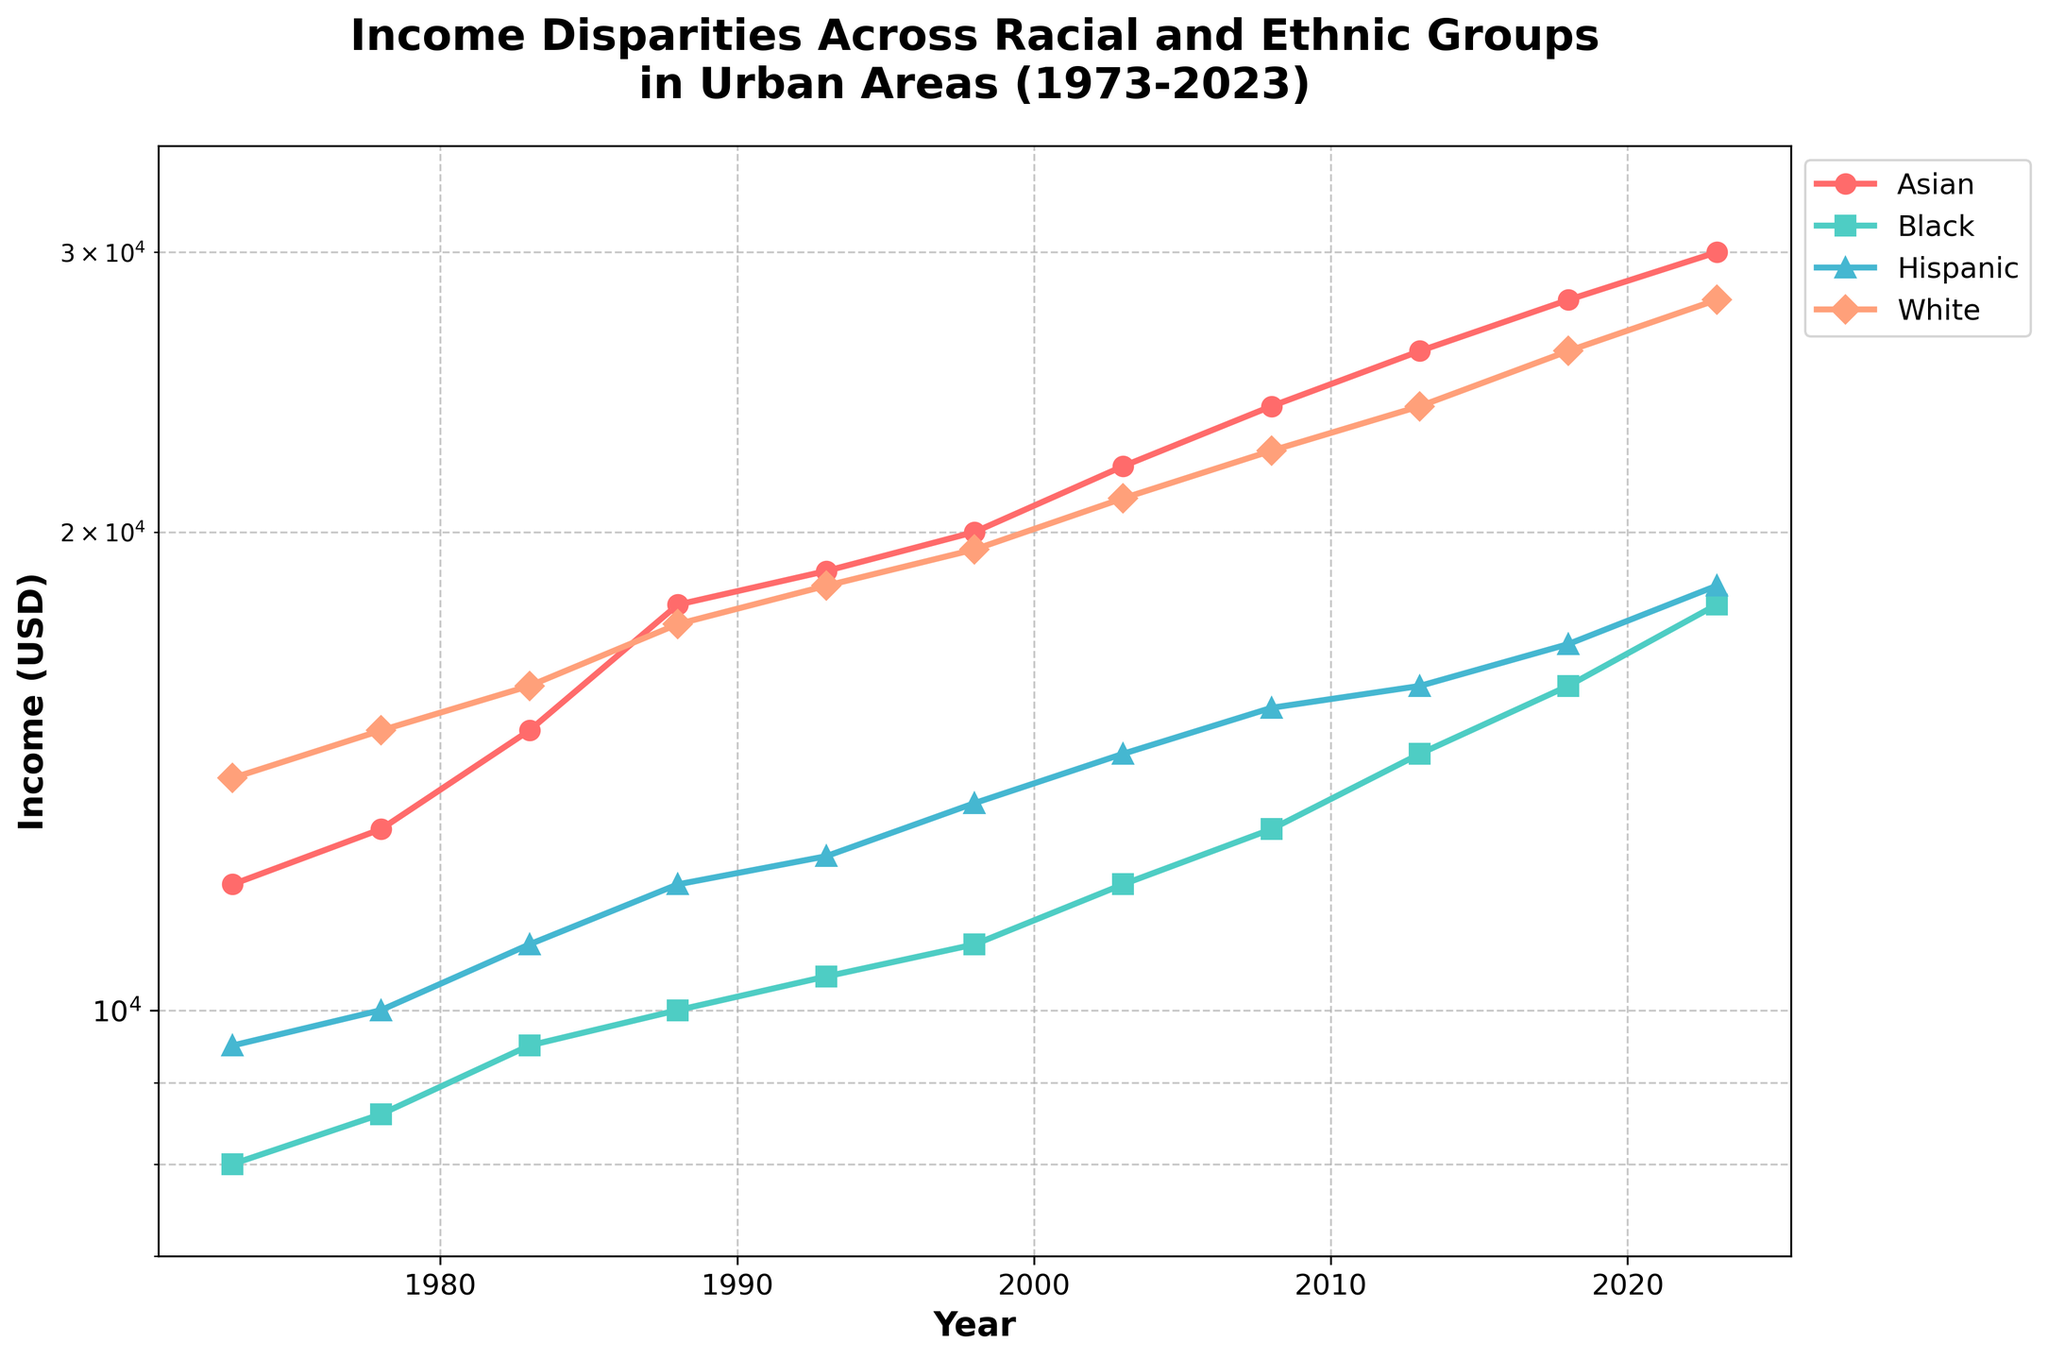What is the title of the chart? The title is located at the top of the chart, written in bold and large font, indicating the subject of the chart.
Answer: Income Disparities Across Racial and Ethnic Groups in Urban Areas (1973-2023) Which year has the highest income for the White group? By looking at the line representing the White group, find the highest data point on the vertical axis, noting the corresponding year on the horizontal axis.
Answer: 2023 Between 1983 and 2008, how much did the income for the Hispanic group increase? Identify the income values for the Hispanic group in 1983 and 2008, then subtract the 1983 value from the 2008 value.
Answer: 4500 What is the difference in income between the Asian and Black groups in 2023? Find the income values for both the Asian and Black groups in 2023, then subtract the Black group's value from the Asian group's value.
Answer: 12000 Which group had the lowest income in 1973? Compare the income values of all the groups in 1973 and identify the lowest value.
Answer: Black By how much did the income for the Black group change from 1973 to 1993? Identify the income values for the Black group in 1973 and 1993, then subtract the 1973 value from the 1993 value.
Answer: 2500 Is there a year where the income of the Hispanic and Black groups are equal? Compare the income values of the Hispanic and Black groups across all years to find any year where they are equal.
Answer: No How does the trend in income for the Asian group compare to the trend for the Hispanic group over the 50 years? Examine the slopes and patterns of the lines representing the Asian and Hispanic groups to determine if they rise, fall, remain steady, or have similar behavior over time.
Answer: Both increase, but the Asian group increases faster Does the White group consistently have the highest income across all years? Check the income values for the White group and compare them with the values of other groups across all years to see if it consistently remains the highest.
Answer: Yes What is the average income for the Black group across all the years shown? Add all the income values for the Black group from 1973 to 2023 and divide by the number of years (11) to get the average.
Answer: 12000 